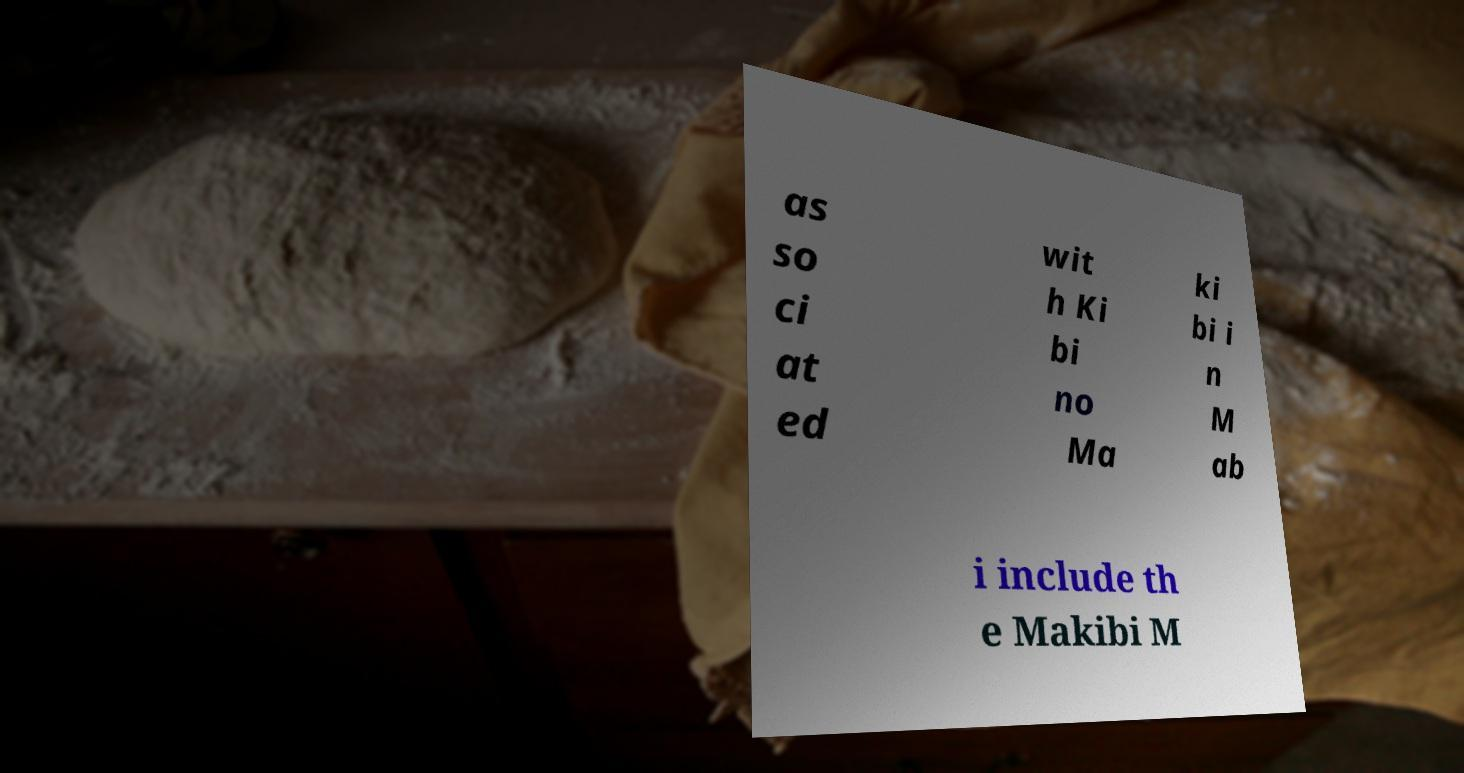Please read and relay the text visible in this image. What does it say? as so ci at ed wit h Ki bi no Ma ki bi i n M ab i include th e Makibi M 